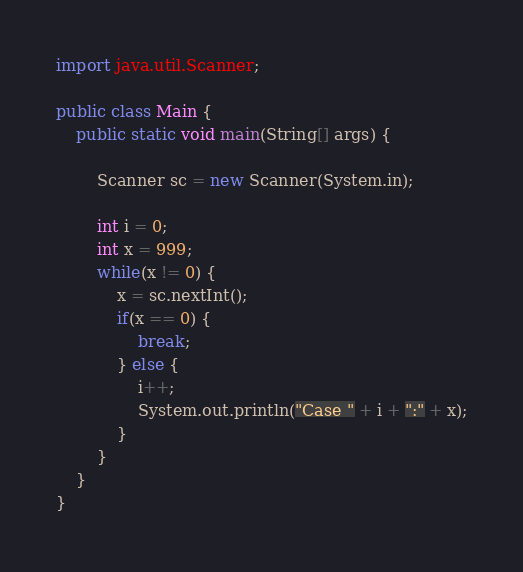<code> <loc_0><loc_0><loc_500><loc_500><_Java_>import java.util.Scanner;

public class Main {
	public static void main(String[] args) {
		
		Scanner sc = new Scanner(System.in);
		
		int i = 0;
		int x = 999;
		while(x != 0) {
			x = sc.nextInt();
			if(x == 0) {
				break;
			} else {
				i++;
				System.out.println("Case " + i + ":" + x);
			}
		}
	}
}</code> 